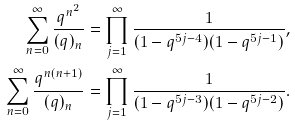<formula> <loc_0><loc_0><loc_500><loc_500>\sum _ { n = 0 } ^ { \infty } \frac { q ^ { n ^ { 2 } } } { ( q ) _ { n } } & = \prod _ { j = 1 } ^ { \infty } \frac { 1 } { ( 1 - q ^ { 5 j - 4 } ) ( 1 - q ^ { 5 j - 1 } ) } , \\ \sum _ { n = 0 } ^ { \infty } \frac { q ^ { n ( n + 1 ) } } { ( q ) _ { n } } & = \prod _ { j = 1 } ^ { \infty } \frac { 1 } { ( 1 - q ^ { 5 j - 3 } ) ( 1 - q ^ { 5 j - 2 } ) } .</formula> 